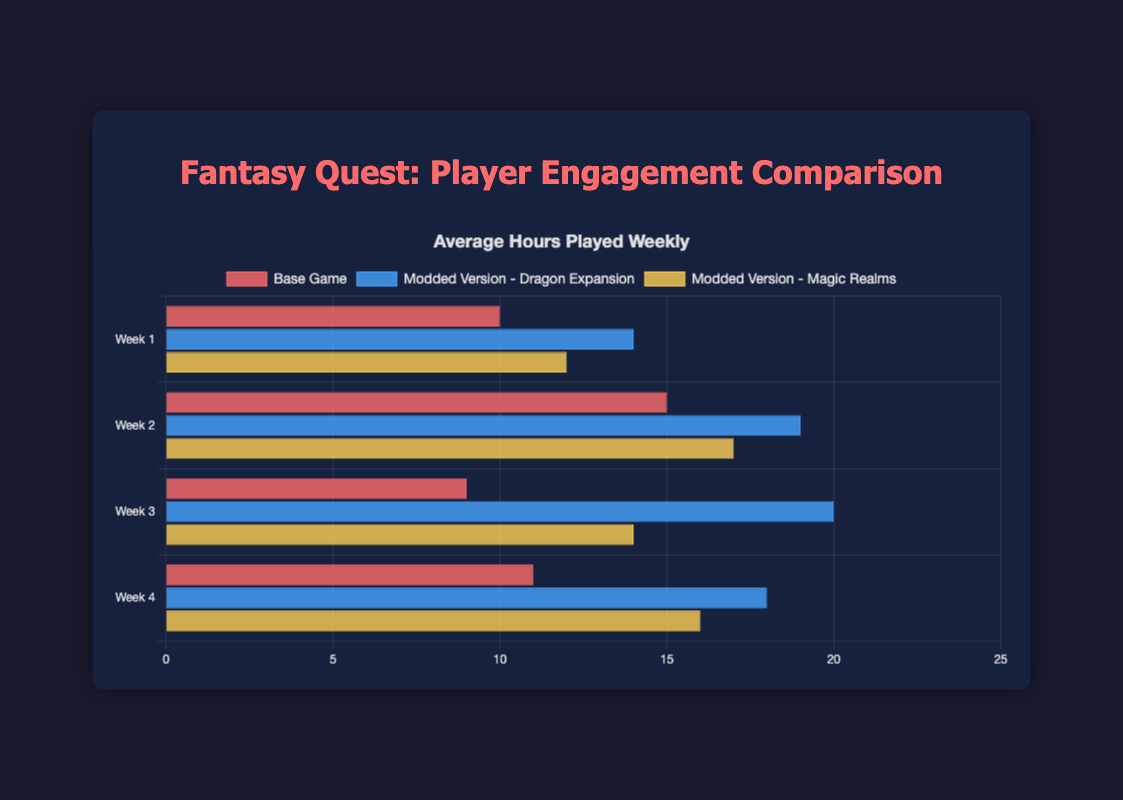What's the average number of hours played in Week 2 across the different versions? To find the average, sum the average hours played in Week 2 for all versions and divide by the number of versions. The values are 15 (Base Game), 19 (Dragon Expansion), and 17 (Magic Realms). Total sum is 15 + 19 + 17 = 51, and there are 3 versions, so the average is 51 / 3 = 17.
Answer: 17 Which version has the highest average hours played in Week 3? Compare the average hours played in Week 3 across the versions: Base Game (9 hours), Dragon Expansion (20 hours), Magic Realms (14 hours). The highest value is 20 hours associated with the Dragon Expansion.
Answer: Dragon Expansion Which day has the lowest average sessions in the Base Game? By looking at the Base Game's sessions per day data, find the lowest value among Monday (4), Tuesday (3.8), Wednesday (4.2), Thursday (3.7), Friday (5), Saturday (6), and Sunday (6.5). The lowest value is 3.7 on Thursday.
Answer: Thursday Comparing the Dragon Expansion and Magic Realms, which had more unique players in February? Compare the unique players in February for Dragon Expansion (8500) and Magic Realms (10000). Magic Realms has more unique players in February.
Answer: Magic Realms On which week does the Base Game show the highest average hours played? Compare the weekly average hours played in the Base Game: Week 1 (10), Week 2 (15), Week 3 (9), Week 4 (11). The highest value is 15 on Week 2.
Answer: Week 2 Summing up the average hours played in Week 1 across all versions, what's the total? Sum the average hours played in Week 1 for all versions: Base Game (10), Dragon Expansion (14), Magic Realms (12). The total sum is 10 + 14 + 12 = 36.
Answer: 36 Which day has the highest average sessions in the Magic Realms version? Check Magic Realms' sessions per day: Monday (4.5), Tuesday (4.7), Wednesday (5), Thursday (4.5), Friday (6.2), Saturday (7), Sunday (7.5). The highest value is 7.5 on Sunday.
Answer: Sunday What is the difference in unique players between January and April for the Base Game? Calculate the difference between unique players in January (10000) and April (9000) for the Base Game. The difference is 10000 - 9000 = 1000.
Answer: 1000 Which version shows the least fluctuation in weekly average hours played? Analyze the weekly average hours played for each version: Base Game (10, 15, 9, 11), Dragon Expansion (14, 19, 20, 18), Magic Realms (12, 17, 14, 16). The Base Game has the least range (15-9=6).
Answer: Base Game 